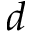<formula> <loc_0><loc_0><loc_500><loc_500>d</formula> 